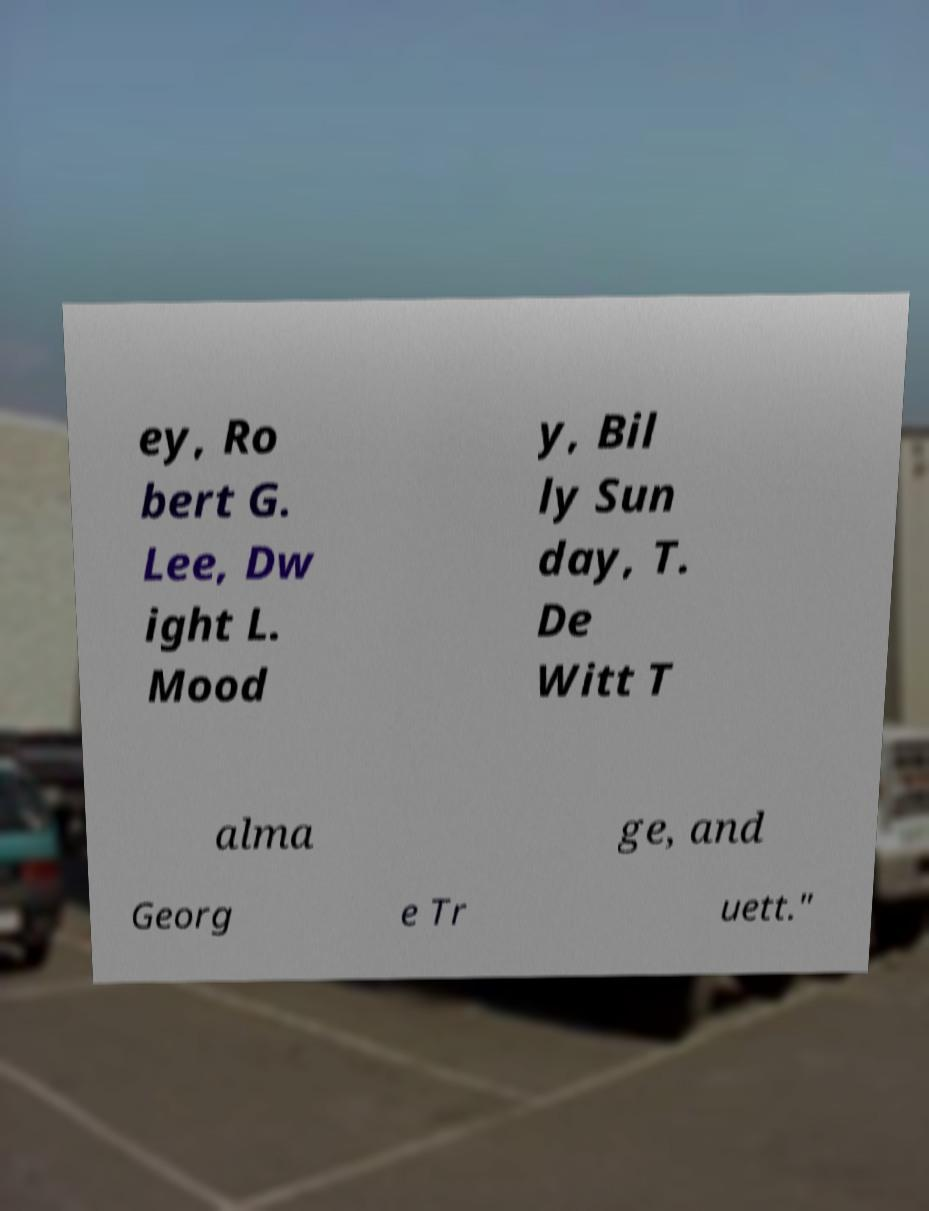There's text embedded in this image that I need extracted. Can you transcribe it verbatim? ey, Ro bert G. Lee, Dw ight L. Mood y, Bil ly Sun day, T. De Witt T alma ge, and Georg e Tr uett." 